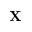Convert formula to latex. <formula><loc_0><loc_0><loc_500><loc_500>\mathbf X</formula> 